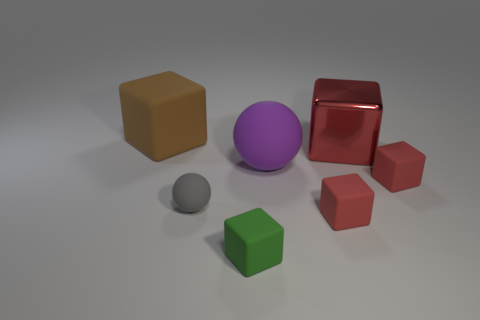Is the number of small gray balls that are in front of the green rubber block less than the number of big yellow metallic blocks?
Offer a terse response. No. Does the green cube have the same size as the red metallic object?
Keep it short and to the point. No. There is a gray ball that is made of the same material as the green thing; what is its size?
Provide a succinct answer. Small. How many small rubber objects have the same color as the large rubber cube?
Provide a succinct answer. 0. Are there fewer metal things that are to the left of the large purple object than small things that are in front of the green cube?
Offer a terse response. No. Does the small thing that is behind the tiny gray rubber object have the same shape as the large purple rubber object?
Offer a very short reply. No. Is there anything else that is the same material as the big purple ball?
Offer a terse response. Yes. Does the large thing on the right side of the large purple sphere have the same material as the purple ball?
Make the answer very short. No. There is a big block that is in front of the matte cube behind the tiny rubber thing that is to the right of the large red block; what is it made of?
Your answer should be very brief. Metal. What number of other things are there of the same shape as the purple matte object?
Your answer should be compact. 1. 